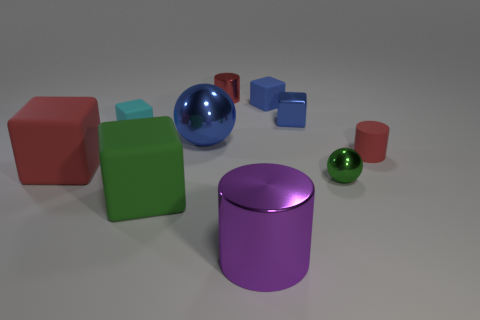What number of things are large metal cylinders or small cyan things? In the image, there is a total of one large metal cylinder and two small cyan objects, which altogether makes three items fitting the description. 